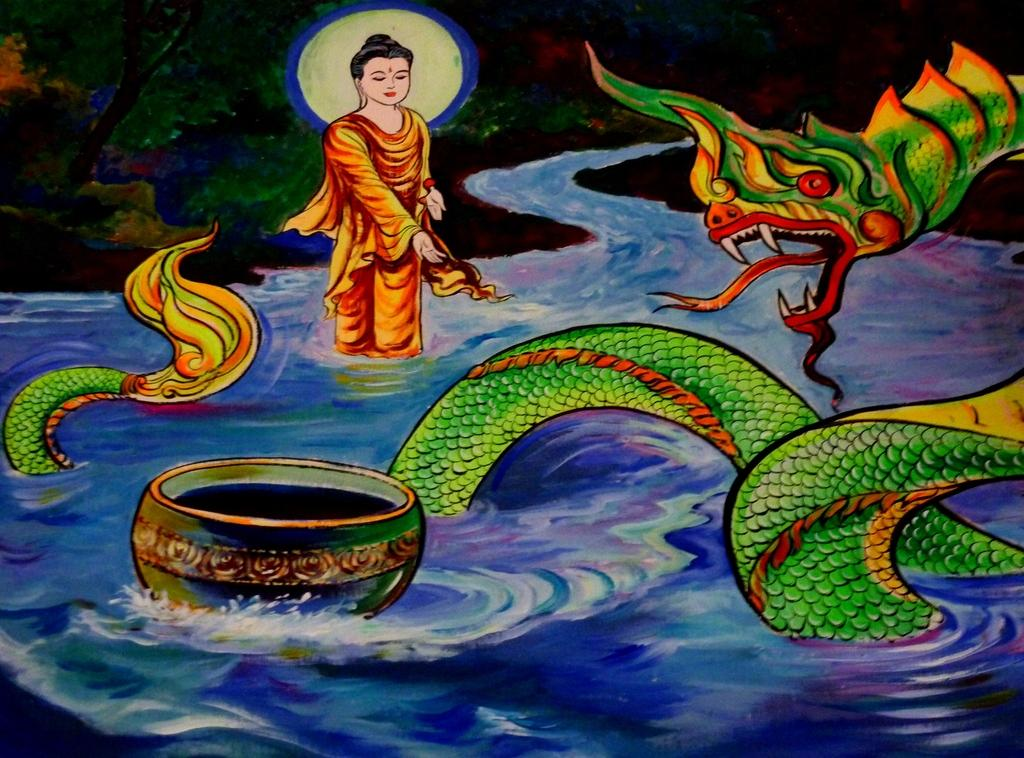What is the main subject of the image? There is a painting in the image. What elements are present in the painting? The painting contains a person, water, trees, and a snake. Where is the kettle located in the painting? There is no kettle present in the painting; it only contains a person, water, trees, and a snake. What direction is the sun facing in the painting? There is no sun present in the painting; it only contains a person, water, trees, and a snake. 